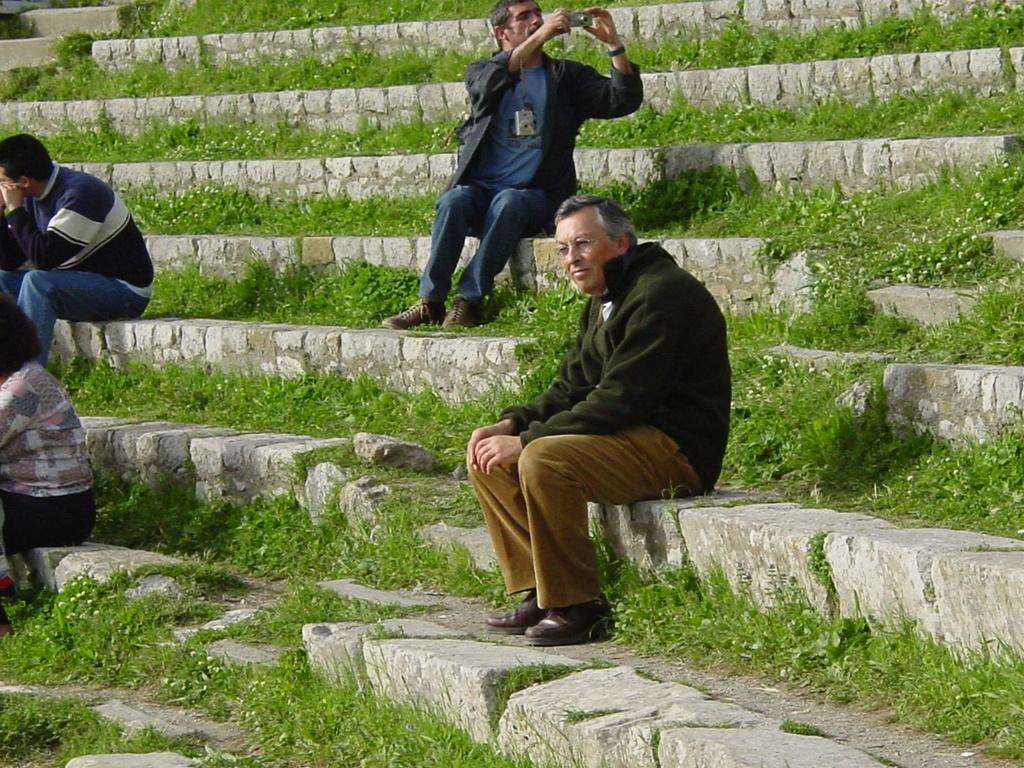Describe this image in one or two sentences. In this picture we can see four people sitting on steps and a man holding a camera with his hands and in the background we can see plants. 